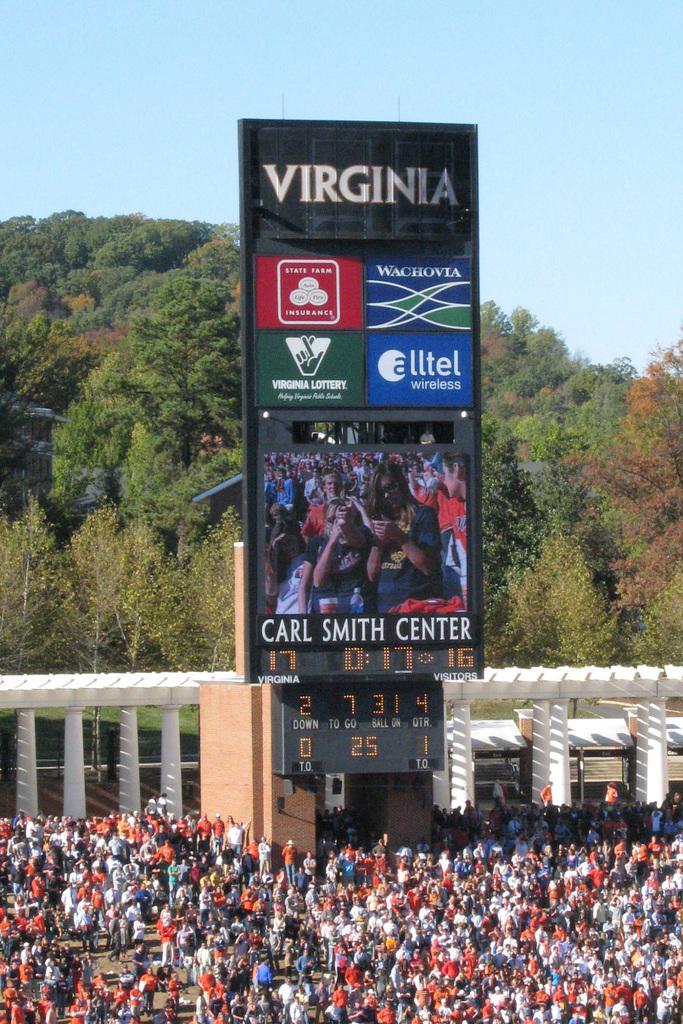How much time is left on the game clock?
Offer a very short reply. 0:17. 